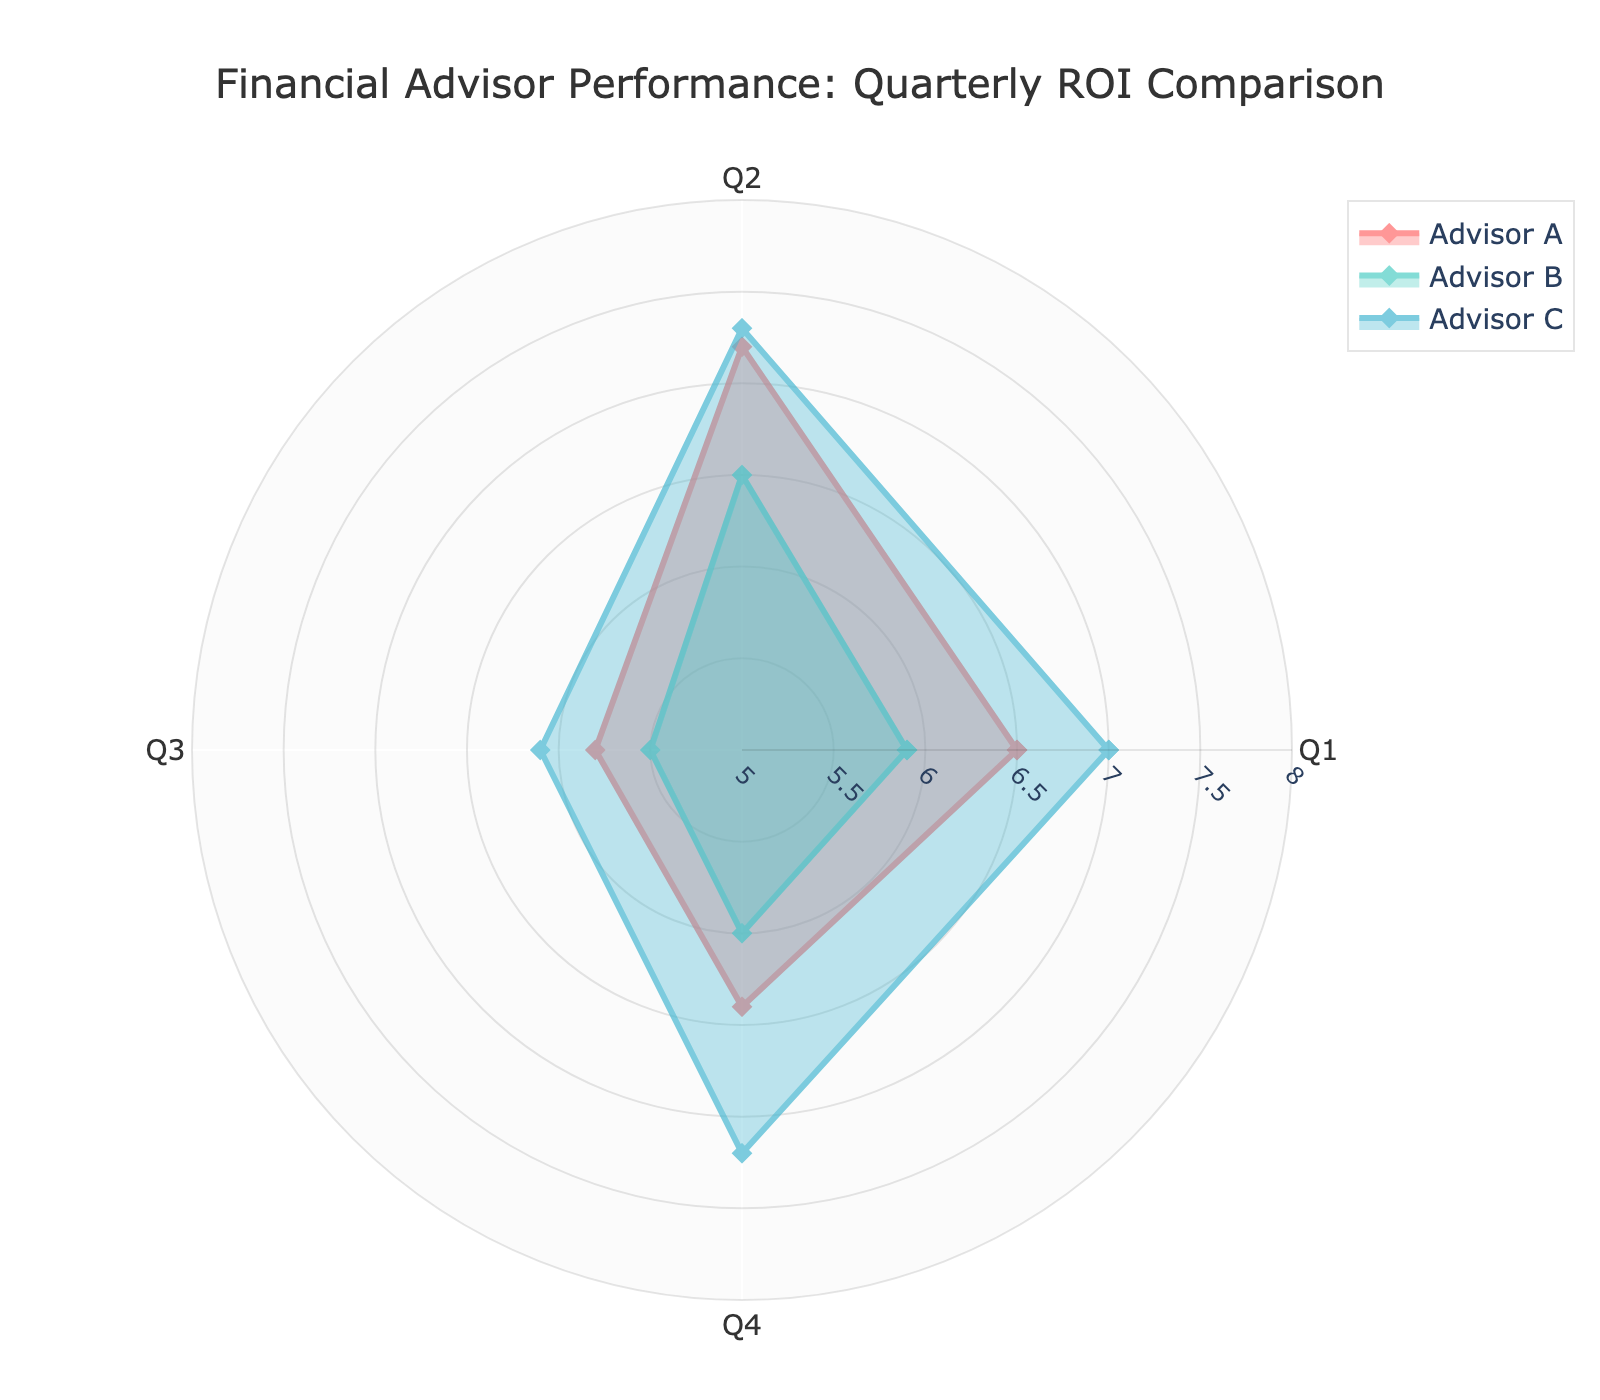what is the title of the chart? The title of the chart is prominently displayed at the top of the figure.
Answer: Financial Advisor Performance: Quarterly ROI Comparison How many advisors are being compared in the figure? We observe three distinct data points with unique color representations corresponding to different advisors.
Answer: Three Which advisor has the highest Return on Investment in Q2? From the graphical representation, the data point for Advisor C extends furthest along the Q2 axis.
Answer: Advisor C What is the average Return on Investment for Advisor B over the four quarters? Calculate the sum of the values for Advisor B across all quarters (5.9 + 6.5 + 5.5 + 6.0 = 23.9), then divide by the number of quarters (4).
Answer: 5.975 Which quarter shows the largest difference in Return on Investment between Advisor A and Advisor B? Compare the values for each quarter: 
Q1: 6.5 vs. 5.9 (0.6) 
Q2: 7.2 vs. 6.5 (0.7) 
Q3: 5.8 vs. 5.5 (0.3) 
Q4: 6.4 vs. 6.0 (0.4). The largest difference is in Q2.
Answer: Q2 What is the range of Return on Investment values for Advisor C? The range is the difference between Advisor C's highest (7.3) and lowest (6.1) ROI values.
Answer: 1.2 Which advisor shows the most consistent performance across all quarters (i.e., the smallest range in Return on Investment)? Calculate the range for each advisor's ROI values: 
Advisor A: Max(7.2)-Min(5.8)=1.4 
Advisor B: Max(6.5)-Min(5.5)=1 
Advisor C: Max(7.3)-Min(6.1)=1.2. 
Advisor B has the smallest range.
Answer: Advisor B In which quarter does Advisor C outperform both Advisor A and Advisor B? Compare the ROI values in each quarter for Advisor C:
Q1: 7.0 (C) vs 6.5 (A) and 5.9 (B)
Q2: 7.3 (C) vs 7.2 (A) and 6.5 (B)
Q3: 6.1 (C) vs 5.8 (A) and 5.5 (B)
Q4: 7.2 (C) vs 6.4 (A) and 6.0 (B). 
Advisor C outperforms both in Q1, Q3, and Q4.
Answer: Q1, Q3, Q4 In which quarter do all advisors have their lowest Return on Investment? Compare lowest ROIs per quarter:
Q1: A (6.5), B (5.9), C (7.0)
Q2: A (7.2), B (6.5), C (7.3)
Q3: A (5.8), B (5.5), C (6.1)
Q4: A (6.4), B (6.0), C (7.2). 
Q3 has the lowest for all.
Answer: Q3 What is the total Return on Investment for Advisor A and Advisor C combined in Q4? Add the ROI values for both advisors in Q4: 6.4 (A) + 7.2 (C).
Answer: 13.6 